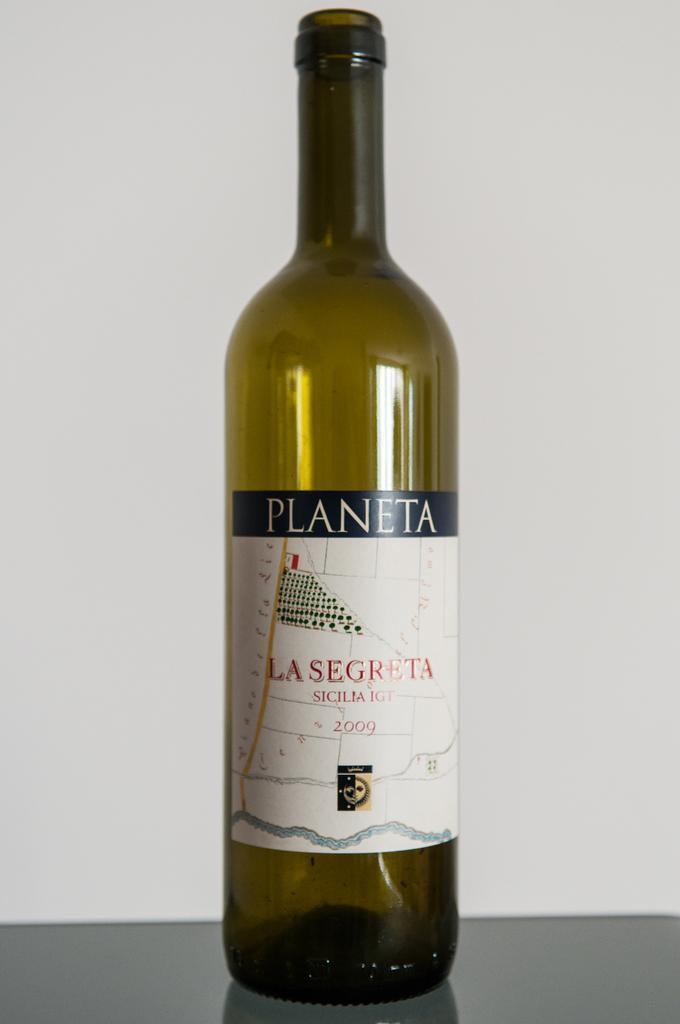How would you summarize this image in a sentence or two? In this image, there is a beverage bottle kept on the floor. The background wall is white in color. This image is taken inside a room. 